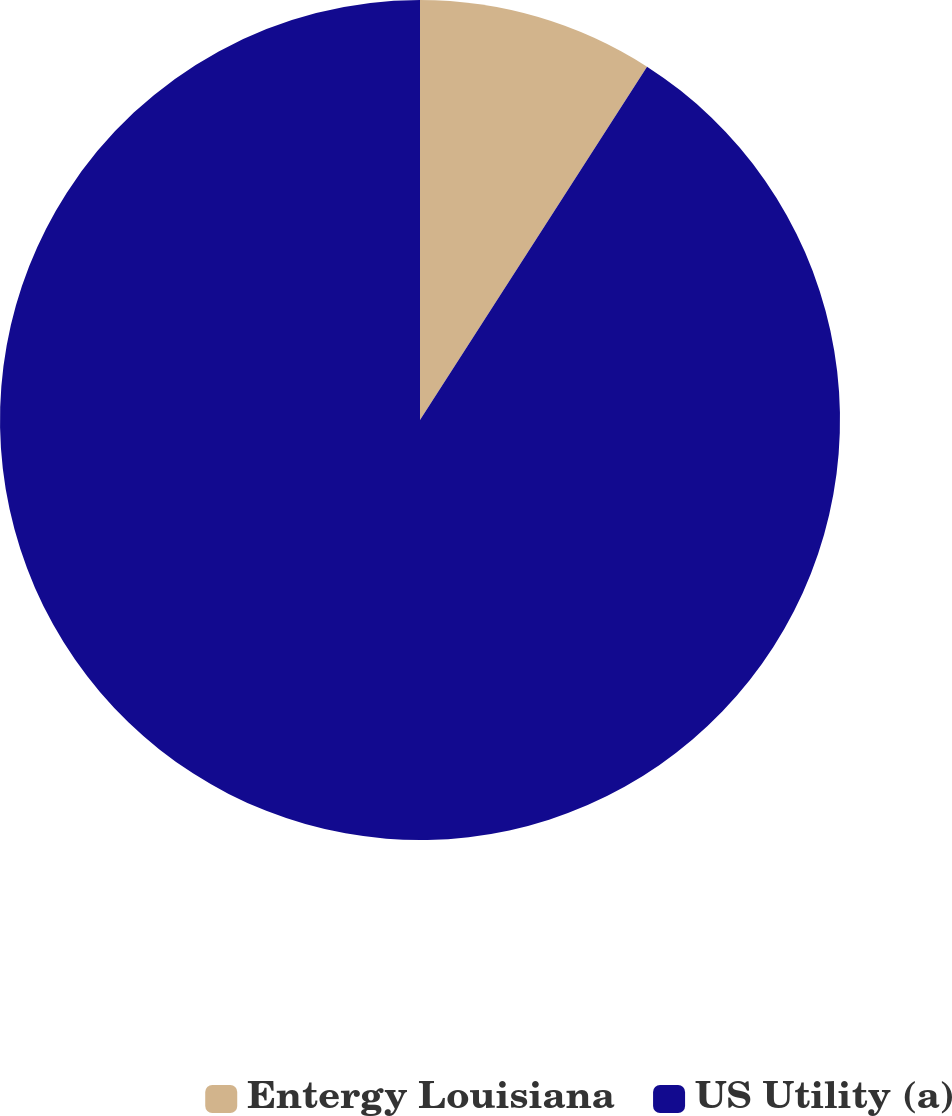<chart> <loc_0><loc_0><loc_500><loc_500><pie_chart><fcel>Entergy Louisiana<fcel>US Utility (a)<nl><fcel>9.09%<fcel>90.91%<nl></chart> 